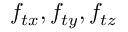Convert formula to latex. <formula><loc_0><loc_0><loc_500><loc_500>f _ { t x } , f _ { t y } , f _ { t z }</formula> 